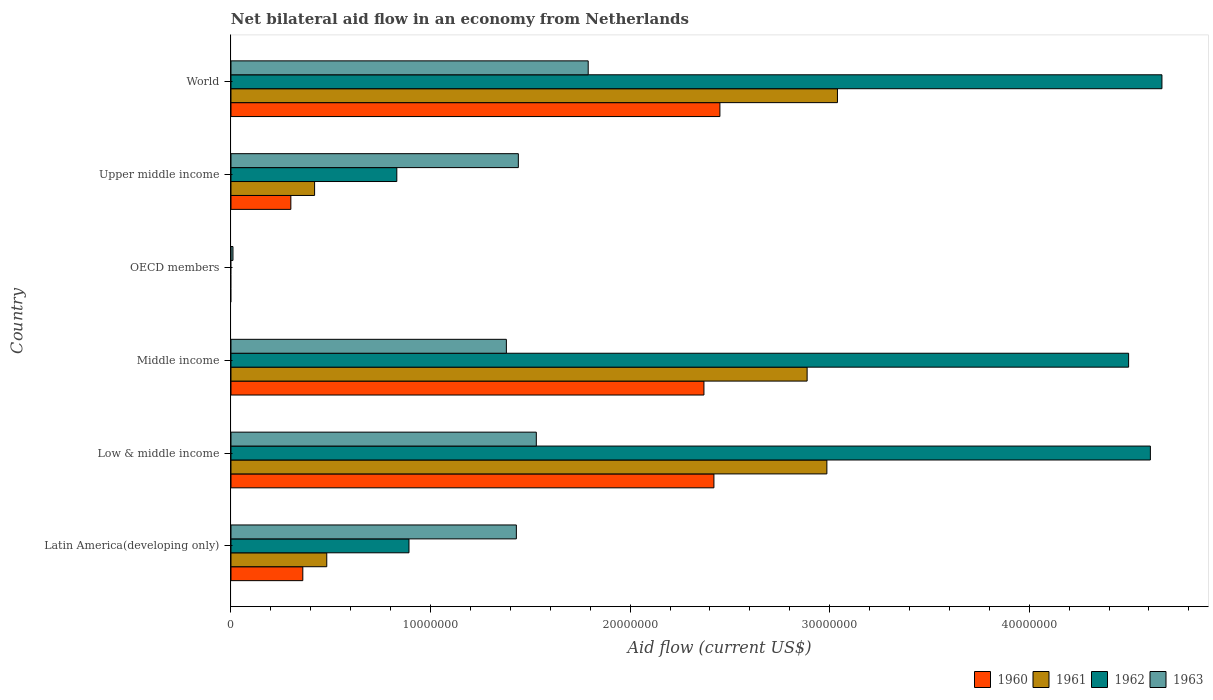How many different coloured bars are there?
Make the answer very short. 4. Are the number of bars per tick equal to the number of legend labels?
Give a very brief answer. No. How many bars are there on the 4th tick from the bottom?
Your response must be concise. 1. In how many cases, is the number of bars for a given country not equal to the number of legend labels?
Keep it short and to the point. 1. What is the net bilateral aid flow in 1961 in Middle income?
Provide a succinct answer. 2.89e+07. Across all countries, what is the maximum net bilateral aid flow in 1963?
Your response must be concise. 1.79e+07. What is the total net bilateral aid flow in 1963 in the graph?
Offer a very short reply. 7.58e+07. What is the difference between the net bilateral aid flow in 1961 in Latin America(developing only) and that in World?
Keep it short and to the point. -2.56e+07. What is the difference between the net bilateral aid flow in 1960 in OECD members and the net bilateral aid flow in 1961 in Latin America(developing only)?
Ensure brevity in your answer.  -4.80e+06. What is the average net bilateral aid flow in 1961 per country?
Offer a very short reply. 1.64e+07. What is the difference between the net bilateral aid flow in 1960 and net bilateral aid flow in 1963 in Middle income?
Make the answer very short. 9.90e+06. What is the ratio of the net bilateral aid flow in 1962 in Low & middle income to that in Upper middle income?
Your answer should be very brief. 5.54. Is the difference between the net bilateral aid flow in 1960 in Middle income and Upper middle income greater than the difference between the net bilateral aid flow in 1963 in Middle income and Upper middle income?
Your answer should be very brief. Yes. What is the difference between the highest and the lowest net bilateral aid flow in 1963?
Ensure brevity in your answer.  1.78e+07. What is the difference between two consecutive major ticks on the X-axis?
Give a very brief answer. 1.00e+07. Are the values on the major ticks of X-axis written in scientific E-notation?
Ensure brevity in your answer.  No. Does the graph contain any zero values?
Offer a very short reply. Yes. Does the graph contain grids?
Keep it short and to the point. No. Where does the legend appear in the graph?
Provide a short and direct response. Bottom right. What is the title of the graph?
Make the answer very short. Net bilateral aid flow in an economy from Netherlands. What is the label or title of the Y-axis?
Offer a very short reply. Country. What is the Aid flow (current US$) in 1960 in Latin America(developing only)?
Make the answer very short. 3.60e+06. What is the Aid flow (current US$) of 1961 in Latin America(developing only)?
Your response must be concise. 4.80e+06. What is the Aid flow (current US$) of 1962 in Latin America(developing only)?
Your response must be concise. 8.92e+06. What is the Aid flow (current US$) in 1963 in Latin America(developing only)?
Ensure brevity in your answer.  1.43e+07. What is the Aid flow (current US$) in 1960 in Low & middle income?
Keep it short and to the point. 2.42e+07. What is the Aid flow (current US$) in 1961 in Low & middle income?
Offer a very short reply. 2.99e+07. What is the Aid flow (current US$) in 1962 in Low & middle income?
Your answer should be compact. 4.61e+07. What is the Aid flow (current US$) in 1963 in Low & middle income?
Give a very brief answer. 1.53e+07. What is the Aid flow (current US$) in 1960 in Middle income?
Make the answer very short. 2.37e+07. What is the Aid flow (current US$) in 1961 in Middle income?
Your answer should be compact. 2.89e+07. What is the Aid flow (current US$) of 1962 in Middle income?
Ensure brevity in your answer.  4.50e+07. What is the Aid flow (current US$) of 1963 in Middle income?
Give a very brief answer. 1.38e+07. What is the Aid flow (current US$) of 1960 in OECD members?
Offer a very short reply. 0. What is the Aid flow (current US$) in 1961 in OECD members?
Your answer should be compact. 0. What is the Aid flow (current US$) in 1962 in OECD members?
Make the answer very short. 0. What is the Aid flow (current US$) of 1963 in OECD members?
Provide a short and direct response. 1.00e+05. What is the Aid flow (current US$) in 1960 in Upper middle income?
Ensure brevity in your answer.  3.00e+06. What is the Aid flow (current US$) of 1961 in Upper middle income?
Give a very brief answer. 4.19e+06. What is the Aid flow (current US$) of 1962 in Upper middle income?
Your response must be concise. 8.31e+06. What is the Aid flow (current US$) in 1963 in Upper middle income?
Offer a terse response. 1.44e+07. What is the Aid flow (current US$) of 1960 in World?
Your response must be concise. 2.45e+07. What is the Aid flow (current US$) in 1961 in World?
Give a very brief answer. 3.04e+07. What is the Aid flow (current US$) of 1962 in World?
Provide a succinct answer. 4.66e+07. What is the Aid flow (current US$) of 1963 in World?
Ensure brevity in your answer.  1.79e+07. Across all countries, what is the maximum Aid flow (current US$) in 1960?
Offer a very short reply. 2.45e+07. Across all countries, what is the maximum Aid flow (current US$) of 1961?
Your response must be concise. 3.04e+07. Across all countries, what is the maximum Aid flow (current US$) of 1962?
Offer a terse response. 4.66e+07. Across all countries, what is the maximum Aid flow (current US$) of 1963?
Make the answer very short. 1.79e+07. Across all countries, what is the minimum Aid flow (current US$) of 1960?
Ensure brevity in your answer.  0. Across all countries, what is the minimum Aid flow (current US$) in 1963?
Offer a terse response. 1.00e+05. What is the total Aid flow (current US$) in 1960 in the graph?
Give a very brief answer. 7.90e+07. What is the total Aid flow (current US$) of 1961 in the graph?
Provide a short and direct response. 9.81e+07. What is the total Aid flow (current US$) in 1962 in the graph?
Offer a very short reply. 1.55e+08. What is the total Aid flow (current US$) in 1963 in the graph?
Make the answer very short. 7.58e+07. What is the difference between the Aid flow (current US$) in 1960 in Latin America(developing only) and that in Low & middle income?
Offer a terse response. -2.06e+07. What is the difference between the Aid flow (current US$) of 1961 in Latin America(developing only) and that in Low & middle income?
Your response must be concise. -2.51e+07. What is the difference between the Aid flow (current US$) of 1962 in Latin America(developing only) and that in Low & middle income?
Provide a short and direct response. -3.72e+07. What is the difference between the Aid flow (current US$) of 1963 in Latin America(developing only) and that in Low & middle income?
Offer a very short reply. -1.00e+06. What is the difference between the Aid flow (current US$) of 1960 in Latin America(developing only) and that in Middle income?
Your answer should be very brief. -2.01e+07. What is the difference between the Aid flow (current US$) of 1961 in Latin America(developing only) and that in Middle income?
Your response must be concise. -2.41e+07. What is the difference between the Aid flow (current US$) in 1962 in Latin America(developing only) and that in Middle income?
Provide a short and direct response. -3.61e+07. What is the difference between the Aid flow (current US$) in 1963 in Latin America(developing only) and that in OECD members?
Your answer should be compact. 1.42e+07. What is the difference between the Aid flow (current US$) in 1960 in Latin America(developing only) and that in Upper middle income?
Your answer should be compact. 6.00e+05. What is the difference between the Aid flow (current US$) of 1962 in Latin America(developing only) and that in Upper middle income?
Ensure brevity in your answer.  6.10e+05. What is the difference between the Aid flow (current US$) in 1963 in Latin America(developing only) and that in Upper middle income?
Offer a very short reply. -1.00e+05. What is the difference between the Aid flow (current US$) of 1960 in Latin America(developing only) and that in World?
Keep it short and to the point. -2.09e+07. What is the difference between the Aid flow (current US$) of 1961 in Latin America(developing only) and that in World?
Provide a short and direct response. -2.56e+07. What is the difference between the Aid flow (current US$) of 1962 in Latin America(developing only) and that in World?
Your answer should be compact. -3.77e+07. What is the difference between the Aid flow (current US$) in 1963 in Latin America(developing only) and that in World?
Provide a succinct answer. -3.60e+06. What is the difference between the Aid flow (current US$) of 1960 in Low & middle income and that in Middle income?
Keep it short and to the point. 5.00e+05. What is the difference between the Aid flow (current US$) of 1961 in Low & middle income and that in Middle income?
Provide a succinct answer. 9.90e+05. What is the difference between the Aid flow (current US$) in 1962 in Low & middle income and that in Middle income?
Keep it short and to the point. 1.09e+06. What is the difference between the Aid flow (current US$) of 1963 in Low & middle income and that in Middle income?
Make the answer very short. 1.50e+06. What is the difference between the Aid flow (current US$) in 1963 in Low & middle income and that in OECD members?
Your answer should be compact. 1.52e+07. What is the difference between the Aid flow (current US$) of 1960 in Low & middle income and that in Upper middle income?
Give a very brief answer. 2.12e+07. What is the difference between the Aid flow (current US$) of 1961 in Low & middle income and that in Upper middle income?
Offer a terse response. 2.57e+07. What is the difference between the Aid flow (current US$) of 1962 in Low & middle income and that in Upper middle income?
Keep it short and to the point. 3.78e+07. What is the difference between the Aid flow (current US$) in 1963 in Low & middle income and that in Upper middle income?
Your response must be concise. 9.00e+05. What is the difference between the Aid flow (current US$) in 1960 in Low & middle income and that in World?
Your answer should be compact. -3.00e+05. What is the difference between the Aid flow (current US$) of 1961 in Low & middle income and that in World?
Provide a succinct answer. -5.30e+05. What is the difference between the Aid flow (current US$) in 1962 in Low & middle income and that in World?
Your answer should be very brief. -5.80e+05. What is the difference between the Aid flow (current US$) of 1963 in Low & middle income and that in World?
Make the answer very short. -2.60e+06. What is the difference between the Aid flow (current US$) in 1963 in Middle income and that in OECD members?
Provide a short and direct response. 1.37e+07. What is the difference between the Aid flow (current US$) in 1960 in Middle income and that in Upper middle income?
Keep it short and to the point. 2.07e+07. What is the difference between the Aid flow (current US$) in 1961 in Middle income and that in Upper middle income?
Offer a very short reply. 2.47e+07. What is the difference between the Aid flow (current US$) of 1962 in Middle income and that in Upper middle income?
Your answer should be very brief. 3.67e+07. What is the difference between the Aid flow (current US$) of 1963 in Middle income and that in Upper middle income?
Give a very brief answer. -6.00e+05. What is the difference between the Aid flow (current US$) of 1960 in Middle income and that in World?
Keep it short and to the point. -8.00e+05. What is the difference between the Aid flow (current US$) in 1961 in Middle income and that in World?
Give a very brief answer. -1.52e+06. What is the difference between the Aid flow (current US$) in 1962 in Middle income and that in World?
Your answer should be very brief. -1.67e+06. What is the difference between the Aid flow (current US$) of 1963 in Middle income and that in World?
Ensure brevity in your answer.  -4.10e+06. What is the difference between the Aid flow (current US$) in 1963 in OECD members and that in Upper middle income?
Your response must be concise. -1.43e+07. What is the difference between the Aid flow (current US$) of 1963 in OECD members and that in World?
Your answer should be very brief. -1.78e+07. What is the difference between the Aid flow (current US$) in 1960 in Upper middle income and that in World?
Offer a terse response. -2.15e+07. What is the difference between the Aid flow (current US$) of 1961 in Upper middle income and that in World?
Offer a terse response. -2.62e+07. What is the difference between the Aid flow (current US$) of 1962 in Upper middle income and that in World?
Your answer should be very brief. -3.83e+07. What is the difference between the Aid flow (current US$) in 1963 in Upper middle income and that in World?
Keep it short and to the point. -3.50e+06. What is the difference between the Aid flow (current US$) of 1960 in Latin America(developing only) and the Aid flow (current US$) of 1961 in Low & middle income?
Offer a terse response. -2.63e+07. What is the difference between the Aid flow (current US$) of 1960 in Latin America(developing only) and the Aid flow (current US$) of 1962 in Low & middle income?
Offer a terse response. -4.25e+07. What is the difference between the Aid flow (current US$) of 1960 in Latin America(developing only) and the Aid flow (current US$) of 1963 in Low & middle income?
Your response must be concise. -1.17e+07. What is the difference between the Aid flow (current US$) in 1961 in Latin America(developing only) and the Aid flow (current US$) in 1962 in Low & middle income?
Provide a short and direct response. -4.13e+07. What is the difference between the Aid flow (current US$) in 1961 in Latin America(developing only) and the Aid flow (current US$) in 1963 in Low & middle income?
Provide a succinct answer. -1.05e+07. What is the difference between the Aid flow (current US$) in 1962 in Latin America(developing only) and the Aid flow (current US$) in 1963 in Low & middle income?
Offer a very short reply. -6.38e+06. What is the difference between the Aid flow (current US$) of 1960 in Latin America(developing only) and the Aid flow (current US$) of 1961 in Middle income?
Your response must be concise. -2.53e+07. What is the difference between the Aid flow (current US$) in 1960 in Latin America(developing only) and the Aid flow (current US$) in 1962 in Middle income?
Offer a terse response. -4.14e+07. What is the difference between the Aid flow (current US$) in 1960 in Latin America(developing only) and the Aid flow (current US$) in 1963 in Middle income?
Keep it short and to the point. -1.02e+07. What is the difference between the Aid flow (current US$) of 1961 in Latin America(developing only) and the Aid flow (current US$) of 1962 in Middle income?
Provide a short and direct response. -4.02e+07. What is the difference between the Aid flow (current US$) of 1961 in Latin America(developing only) and the Aid flow (current US$) of 1963 in Middle income?
Ensure brevity in your answer.  -9.00e+06. What is the difference between the Aid flow (current US$) in 1962 in Latin America(developing only) and the Aid flow (current US$) in 1963 in Middle income?
Keep it short and to the point. -4.88e+06. What is the difference between the Aid flow (current US$) in 1960 in Latin America(developing only) and the Aid flow (current US$) in 1963 in OECD members?
Offer a very short reply. 3.50e+06. What is the difference between the Aid flow (current US$) of 1961 in Latin America(developing only) and the Aid flow (current US$) of 1963 in OECD members?
Make the answer very short. 4.70e+06. What is the difference between the Aid flow (current US$) in 1962 in Latin America(developing only) and the Aid flow (current US$) in 1963 in OECD members?
Offer a very short reply. 8.82e+06. What is the difference between the Aid flow (current US$) in 1960 in Latin America(developing only) and the Aid flow (current US$) in 1961 in Upper middle income?
Give a very brief answer. -5.90e+05. What is the difference between the Aid flow (current US$) in 1960 in Latin America(developing only) and the Aid flow (current US$) in 1962 in Upper middle income?
Your answer should be compact. -4.71e+06. What is the difference between the Aid flow (current US$) of 1960 in Latin America(developing only) and the Aid flow (current US$) of 1963 in Upper middle income?
Your response must be concise. -1.08e+07. What is the difference between the Aid flow (current US$) in 1961 in Latin America(developing only) and the Aid flow (current US$) in 1962 in Upper middle income?
Keep it short and to the point. -3.51e+06. What is the difference between the Aid flow (current US$) of 1961 in Latin America(developing only) and the Aid flow (current US$) of 1963 in Upper middle income?
Keep it short and to the point. -9.60e+06. What is the difference between the Aid flow (current US$) of 1962 in Latin America(developing only) and the Aid flow (current US$) of 1963 in Upper middle income?
Offer a terse response. -5.48e+06. What is the difference between the Aid flow (current US$) in 1960 in Latin America(developing only) and the Aid flow (current US$) in 1961 in World?
Ensure brevity in your answer.  -2.68e+07. What is the difference between the Aid flow (current US$) of 1960 in Latin America(developing only) and the Aid flow (current US$) of 1962 in World?
Your response must be concise. -4.30e+07. What is the difference between the Aid flow (current US$) in 1960 in Latin America(developing only) and the Aid flow (current US$) in 1963 in World?
Provide a succinct answer. -1.43e+07. What is the difference between the Aid flow (current US$) in 1961 in Latin America(developing only) and the Aid flow (current US$) in 1962 in World?
Offer a very short reply. -4.18e+07. What is the difference between the Aid flow (current US$) of 1961 in Latin America(developing only) and the Aid flow (current US$) of 1963 in World?
Make the answer very short. -1.31e+07. What is the difference between the Aid flow (current US$) in 1962 in Latin America(developing only) and the Aid flow (current US$) in 1963 in World?
Give a very brief answer. -8.98e+06. What is the difference between the Aid flow (current US$) of 1960 in Low & middle income and the Aid flow (current US$) of 1961 in Middle income?
Make the answer very short. -4.67e+06. What is the difference between the Aid flow (current US$) of 1960 in Low & middle income and the Aid flow (current US$) of 1962 in Middle income?
Provide a succinct answer. -2.08e+07. What is the difference between the Aid flow (current US$) in 1960 in Low & middle income and the Aid flow (current US$) in 1963 in Middle income?
Ensure brevity in your answer.  1.04e+07. What is the difference between the Aid flow (current US$) in 1961 in Low & middle income and the Aid flow (current US$) in 1962 in Middle income?
Provide a short and direct response. -1.51e+07. What is the difference between the Aid flow (current US$) in 1961 in Low & middle income and the Aid flow (current US$) in 1963 in Middle income?
Your answer should be compact. 1.61e+07. What is the difference between the Aid flow (current US$) in 1962 in Low & middle income and the Aid flow (current US$) in 1963 in Middle income?
Provide a succinct answer. 3.23e+07. What is the difference between the Aid flow (current US$) of 1960 in Low & middle income and the Aid flow (current US$) of 1963 in OECD members?
Offer a terse response. 2.41e+07. What is the difference between the Aid flow (current US$) in 1961 in Low & middle income and the Aid flow (current US$) in 1963 in OECD members?
Offer a very short reply. 2.98e+07. What is the difference between the Aid flow (current US$) in 1962 in Low & middle income and the Aid flow (current US$) in 1963 in OECD members?
Your answer should be very brief. 4.60e+07. What is the difference between the Aid flow (current US$) in 1960 in Low & middle income and the Aid flow (current US$) in 1961 in Upper middle income?
Your response must be concise. 2.00e+07. What is the difference between the Aid flow (current US$) in 1960 in Low & middle income and the Aid flow (current US$) in 1962 in Upper middle income?
Give a very brief answer. 1.59e+07. What is the difference between the Aid flow (current US$) in 1960 in Low & middle income and the Aid flow (current US$) in 1963 in Upper middle income?
Provide a short and direct response. 9.80e+06. What is the difference between the Aid flow (current US$) in 1961 in Low & middle income and the Aid flow (current US$) in 1962 in Upper middle income?
Your response must be concise. 2.16e+07. What is the difference between the Aid flow (current US$) of 1961 in Low & middle income and the Aid flow (current US$) of 1963 in Upper middle income?
Offer a very short reply. 1.55e+07. What is the difference between the Aid flow (current US$) in 1962 in Low & middle income and the Aid flow (current US$) in 1963 in Upper middle income?
Make the answer very short. 3.17e+07. What is the difference between the Aid flow (current US$) in 1960 in Low & middle income and the Aid flow (current US$) in 1961 in World?
Provide a short and direct response. -6.19e+06. What is the difference between the Aid flow (current US$) in 1960 in Low & middle income and the Aid flow (current US$) in 1962 in World?
Offer a terse response. -2.24e+07. What is the difference between the Aid flow (current US$) in 1960 in Low & middle income and the Aid flow (current US$) in 1963 in World?
Provide a succinct answer. 6.30e+06. What is the difference between the Aid flow (current US$) of 1961 in Low & middle income and the Aid flow (current US$) of 1962 in World?
Offer a terse response. -1.68e+07. What is the difference between the Aid flow (current US$) in 1961 in Low & middle income and the Aid flow (current US$) in 1963 in World?
Offer a very short reply. 1.20e+07. What is the difference between the Aid flow (current US$) of 1962 in Low & middle income and the Aid flow (current US$) of 1963 in World?
Provide a short and direct response. 2.82e+07. What is the difference between the Aid flow (current US$) in 1960 in Middle income and the Aid flow (current US$) in 1963 in OECD members?
Give a very brief answer. 2.36e+07. What is the difference between the Aid flow (current US$) of 1961 in Middle income and the Aid flow (current US$) of 1963 in OECD members?
Give a very brief answer. 2.88e+07. What is the difference between the Aid flow (current US$) in 1962 in Middle income and the Aid flow (current US$) in 1963 in OECD members?
Keep it short and to the point. 4.49e+07. What is the difference between the Aid flow (current US$) of 1960 in Middle income and the Aid flow (current US$) of 1961 in Upper middle income?
Your answer should be very brief. 1.95e+07. What is the difference between the Aid flow (current US$) in 1960 in Middle income and the Aid flow (current US$) in 1962 in Upper middle income?
Your response must be concise. 1.54e+07. What is the difference between the Aid flow (current US$) of 1960 in Middle income and the Aid flow (current US$) of 1963 in Upper middle income?
Your response must be concise. 9.30e+06. What is the difference between the Aid flow (current US$) in 1961 in Middle income and the Aid flow (current US$) in 1962 in Upper middle income?
Offer a very short reply. 2.06e+07. What is the difference between the Aid flow (current US$) in 1961 in Middle income and the Aid flow (current US$) in 1963 in Upper middle income?
Offer a terse response. 1.45e+07. What is the difference between the Aid flow (current US$) in 1962 in Middle income and the Aid flow (current US$) in 1963 in Upper middle income?
Make the answer very short. 3.06e+07. What is the difference between the Aid flow (current US$) in 1960 in Middle income and the Aid flow (current US$) in 1961 in World?
Provide a succinct answer. -6.69e+06. What is the difference between the Aid flow (current US$) in 1960 in Middle income and the Aid flow (current US$) in 1962 in World?
Offer a very short reply. -2.30e+07. What is the difference between the Aid flow (current US$) of 1960 in Middle income and the Aid flow (current US$) of 1963 in World?
Your response must be concise. 5.80e+06. What is the difference between the Aid flow (current US$) in 1961 in Middle income and the Aid flow (current US$) in 1962 in World?
Your answer should be compact. -1.78e+07. What is the difference between the Aid flow (current US$) in 1961 in Middle income and the Aid flow (current US$) in 1963 in World?
Keep it short and to the point. 1.10e+07. What is the difference between the Aid flow (current US$) of 1962 in Middle income and the Aid flow (current US$) of 1963 in World?
Provide a short and direct response. 2.71e+07. What is the difference between the Aid flow (current US$) of 1960 in Upper middle income and the Aid flow (current US$) of 1961 in World?
Offer a very short reply. -2.74e+07. What is the difference between the Aid flow (current US$) in 1960 in Upper middle income and the Aid flow (current US$) in 1962 in World?
Your response must be concise. -4.36e+07. What is the difference between the Aid flow (current US$) of 1960 in Upper middle income and the Aid flow (current US$) of 1963 in World?
Provide a short and direct response. -1.49e+07. What is the difference between the Aid flow (current US$) in 1961 in Upper middle income and the Aid flow (current US$) in 1962 in World?
Give a very brief answer. -4.25e+07. What is the difference between the Aid flow (current US$) in 1961 in Upper middle income and the Aid flow (current US$) in 1963 in World?
Give a very brief answer. -1.37e+07. What is the difference between the Aid flow (current US$) of 1962 in Upper middle income and the Aid flow (current US$) of 1963 in World?
Your answer should be compact. -9.59e+06. What is the average Aid flow (current US$) in 1960 per country?
Give a very brief answer. 1.32e+07. What is the average Aid flow (current US$) in 1961 per country?
Offer a terse response. 1.64e+07. What is the average Aid flow (current US$) in 1962 per country?
Make the answer very short. 2.58e+07. What is the average Aid flow (current US$) in 1963 per country?
Give a very brief answer. 1.26e+07. What is the difference between the Aid flow (current US$) of 1960 and Aid flow (current US$) of 1961 in Latin America(developing only)?
Provide a succinct answer. -1.20e+06. What is the difference between the Aid flow (current US$) in 1960 and Aid flow (current US$) in 1962 in Latin America(developing only)?
Give a very brief answer. -5.32e+06. What is the difference between the Aid flow (current US$) of 1960 and Aid flow (current US$) of 1963 in Latin America(developing only)?
Offer a terse response. -1.07e+07. What is the difference between the Aid flow (current US$) in 1961 and Aid flow (current US$) in 1962 in Latin America(developing only)?
Your response must be concise. -4.12e+06. What is the difference between the Aid flow (current US$) in 1961 and Aid flow (current US$) in 1963 in Latin America(developing only)?
Keep it short and to the point. -9.50e+06. What is the difference between the Aid flow (current US$) in 1962 and Aid flow (current US$) in 1963 in Latin America(developing only)?
Provide a succinct answer. -5.38e+06. What is the difference between the Aid flow (current US$) of 1960 and Aid flow (current US$) of 1961 in Low & middle income?
Your response must be concise. -5.66e+06. What is the difference between the Aid flow (current US$) in 1960 and Aid flow (current US$) in 1962 in Low & middle income?
Ensure brevity in your answer.  -2.19e+07. What is the difference between the Aid flow (current US$) in 1960 and Aid flow (current US$) in 1963 in Low & middle income?
Make the answer very short. 8.90e+06. What is the difference between the Aid flow (current US$) of 1961 and Aid flow (current US$) of 1962 in Low & middle income?
Keep it short and to the point. -1.62e+07. What is the difference between the Aid flow (current US$) of 1961 and Aid flow (current US$) of 1963 in Low & middle income?
Give a very brief answer. 1.46e+07. What is the difference between the Aid flow (current US$) in 1962 and Aid flow (current US$) in 1963 in Low & middle income?
Provide a short and direct response. 3.08e+07. What is the difference between the Aid flow (current US$) of 1960 and Aid flow (current US$) of 1961 in Middle income?
Your answer should be compact. -5.17e+06. What is the difference between the Aid flow (current US$) in 1960 and Aid flow (current US$) in 1962 in Middle income?
Offer a very short reply. -2.13e+07. What is the difference between the Aid flow (current US$) in 1960 and Aid flow (current US$) in 1963 in Middle income?
Your answer should be compact. 9.90e+06. What is the difference between the Aid flow (current US$) of 1961 and Aid flow (current US$) of 1962 in Middle income?
Offer a very short reply. -1.61e+07. What is the difference between the Aid flow (current US$) of 1961 and Aid flow (current US$) of 1963 in Middle income?
Offer a very short reply. 1.51e+07. What is the difference between the Aid flow (current US$) in 1962 and Aid flow (current US$) in 1963 in Middle income?
Your answer should be very brief. 3.12e+07. What is the difference between the Aid flow (current US$) in 1960 and Aid flow (current US$) in 1961 in Upper middle income?
Provide a succinct answer. -1.19e+06. What is the difference between the Aid flow (current US$) in 1960 and Aid flow (current US$) in 1962 in Upper middle income?
Your answer should be compact. -5.31e+06. What is the difference between the Aid flow (current US$) of 1960 and Aid flow (current US$) of 1963 in Upper middle income?
Provide a short and direct response. -1.14e+07. What is the difference between the Aid flow (current US$) of 1961 and Aid flow (current US$) of 1962 in Upper middle income?
Your answer should be compact. -4.12e+06. What is the difference between the Aid flow (current US$) in 1961 and Aid flow (current US$) in 1963 in Upper middle income?
Your answer should be compact. -1.02e+07. What is the difference between the Aid flow (current US$) in 1962 and Aid flow (current US$) in 1963 in Upper middle income?
Give a very brief answer. -6.09e+06. What is the difference between the Aid flow (current US$) of 1960 and Aid flow (current US$) of 1961 in World?
Keep it short and to the point. -5.89e+06. What is the difference between the Aid flow (current US$) of 1960 and Aid flow (current US$) of 1962 in World?
Offer a terse response. -2.22e+07. What is the difference between the Aid flow (current US$) of 1960 and Aid flow (current US$) of 1963 in World?
Your response must be concise. 6.60e+06. What is the difference between the Aid flow (current US$) of 1961 and Aid flow (current US$) of 1962 in World?
Make the answer very short. -1.63e+07. What is the difference between the Aid flow (current US$) of 1961 and Aid flow (current US$) of 1963 in World?
Provide a short and direct response. 1.25e+07. What is the difference between the Aid flow (current US$) in 1962 and Aid flow (current US$) in 1963 in World?
Give a very brief answer. 2.88e+07. What is the ratio of the Aid flow (current US$) of 1960 in Latin America(developing only) to that in Low & middle income?
Your answer should be compact. 0.15. What is the ratio of the Aid flow (current US$) of 1961 in Latin America(developing only) to that in Low & middle income?
Provide a succinct answer. 0.16. What is the ratio of the Aid flow (current US$) of 1962 in Latin America(developing only) to that in Low & middle income?
Provide a succinct answer. 0.19. What is the ratio of the Aid flow (current US$) of 1963 in Latin America(developing only) to that in Low & middle income?
Your response must be concise. 0.93. What is the ratio of the Aid flow (current US$) in 1960 in Latin America(developing only) to that in Middle income?
Offer a terse response. 0.15. What is the ratio of the Aid flow (current US$) in 1961 in Latin America(developing only) to that in Middle income?
Your response must be concise. 0.17. What is the ratio of the Aid flow (current US$) in 1962 in Latin America(developing only) to that in Middle income?
Provide a short and direct response. 0.2. What is the ratio of the Aid flow (current US$) of 1963 in Latin America(developing only) to that in Middle income?
Ensure brevity in your answer.  1.04. What is the ratio of the Aid flow (current US$) of 1963 in Latin America(developing only) to that in OECD members?
Make the answer very short. 143. What is the ratio of the Aid flow (current US$) of 1961 in Latin America(developing only) to that in Upper middle income?
Ensure brevity in your answer.  1.15. What is the ratio of the Aid flow (current US$) in 1962 in Latin America(developing only) to that in Upper middle income?
Keep it short and to the point. 1.07. What is the ratio of the Aid flow (current US$) of 1963 in Latin America(developing only) to that in Upper middle income?
Provide a short and direct response. 0.99. What is the ratio of the Aid flow (current US$) of 1960 in Latin America(developing only) to that in World?
Your answer should be very brief. 0.15. What is the ratio of the Aid flow (current US$) in 1961 in Latin America(developing only) to that in World?
Give a very brief answer. 0.16. What is the ratio of the Aid flow (current US$) of 1962 in Latin America(developing only) to that in World?
Offer a very short reply. 0.19. What is the ratio of the Aid flow (current US$) in 1963 in Latin America(developing only) to that in World?
Provide a succinct answer. 0.8. What is the ratio of the Aid flow (current US$) in 1960 in Low & middle income to that in Middle income?
Offer a very short reply. 1.02. What is the ratio of the Aid flow (current US$) in 1961 in Low & middle income to that in Middle income?
Provide a short and direct response. 1.03. What is the ratio of the Aid flow (current US$) in 1962 in Low & middle income to that in Middle income?
Your answer should be compact. 1.02. What is the ratio of the Aid flow (current US$) of 1963 in Low & middle income to that in Middle income?
Offer a terse response. 1.11. What is the ratio of the Aid flow (current US$) in 1963 in Low & middle income to that in OECD members?
Give a very brief answer. 153. What is the ratio of the Aid flow (current US$) in 1960 in Low & middle income to that in Upper middle income?
Offer a very short reply. 8.07. What is the ratio of the Aid flow (current US$) in 1961 in Low & middle income to that in Upper middle income?
Ensure brevity in your answer.  7.13. What is the ratio of the Aid flow (current US$) of 1962 in Low & middle income to that in Upper middle income?
Provide a short and direct response. 5.54. What is the ratio of the Aid flow (current US$) of 1963 in Low & middle income to that in Upper middle income?
Offer a very short reply. 1.06. What is the ratio of the Aid flow (current US$) of 1960 in Low & middle income to that in World?
Provide a short and direct response. 0.99. What is the ratio of the Aid flow (current US$) of 1961 in Low & middle income to that in World?
Your answer should be very brief. 0.98. What is the ratio of the Aid flow (current US$) in 1962 in Low & middle income to that in World?
Give a very brief answer. 0.99. What is the ratio of the Aid flow (current US$) in 1963 in Low & middle income to that in World?
Your response must be concise. 0.85. What is the ratio of the Aid flow (current US$) of 1963 in Middle income to that in OECD members?
Ensure brevity in your answer.  138. What is the ratio of the Aid flow (current US$) in 1960 in Middle income to that in Upper middle income?
Provide a short and direct response. 7.9. What is the ratio of the Aid flow (current US$) in 1961 in Middle income to that in Upper middle income?
Provide a short and direct response. 6.89. What is the ratio of the Aid flow (current US$) in 1962 in Middle income to that in Upper middle income?
Make the answer very short. 5.41. What is the ratio of the Aid flow (current US$) in 1963 in Middle income to that in Upper middle income?
Keep it short and to the point. 0.96. What is the ratio of the Aid flow (current US$) in 1960 in Middle income to that in World?
Provide a succinct answer. 0.97. What is the ratio of the Aid flow (current US$) of 1961 in Middle income to that in World?
Ensure brevity in your answer.  0.95. What is the ratio of the Aid flow (current US$) in 1962 in Middle income to that in World?
Make the answer very short. 0.96. What is the ratio of the Aid flow (current US$) in 1963 in Middle income to that in World?
Your answer should be compact. 0.77. What is the ratio of the Aid flow (current US$) of 1963 in OECD members to that in Upper middle income?
Your answer should be very brief. 0.01. What is the ratio of the Aid flow (current US$) of 1963 in OECD members to that in World?
Keep it short and to the point. 0.01. What is the ratio of the Aid flow (current US$) in 1960 in Upper middle income to that in World?
Your response must be concise. 0.12. What is the ratio of the Aid flow (current US$) of 1961 in Upper middle income to that in World?
Provide a succinct answer. 0.14. What is the ratio of the Aid flow (current US$) of 1962 in Upper middle income to that in World?
Make the answer very short. 0.18. What is the ratio of the Aid flow (current US$) in 1963 in Upper middle income to that in World?
Make the answer very short. 0.8. What is the difference between the highest and the second highest Aid flow (current US$) in 1960?
Your answer should be very brief. 3.00e+05. What is the difference between the highest and the second highest Aid flow (current US$) in 1961?
Provide a short and direct response. 5.30e+05. What is the difference between the highest and the second highest Aid flow (current US$) in 1962?
Your answer should be very brief. 5.80e+05. What is the difference between the highest and the second highest Aid flow (current US$) of 1963?
Make the answer very short. 2.60e+06. What is the difference between the highest and the lowest Aid flow (current US$) in 1960?
Your answer should be very brief. 2.45e+07. What is the difference between the highest and the lowest Aid flow (current US$) of 1961?
Provide a succinct answer. 3.04e+07. What is the difference between the highest and the lowest Aid flow (current US$) in 1962?
Offer a terse response. 4.66e+07. What is the difference between the highest and the lowest Aid flow (current US$) of 1963?
Offer a very short reply. 1.78e+07. 